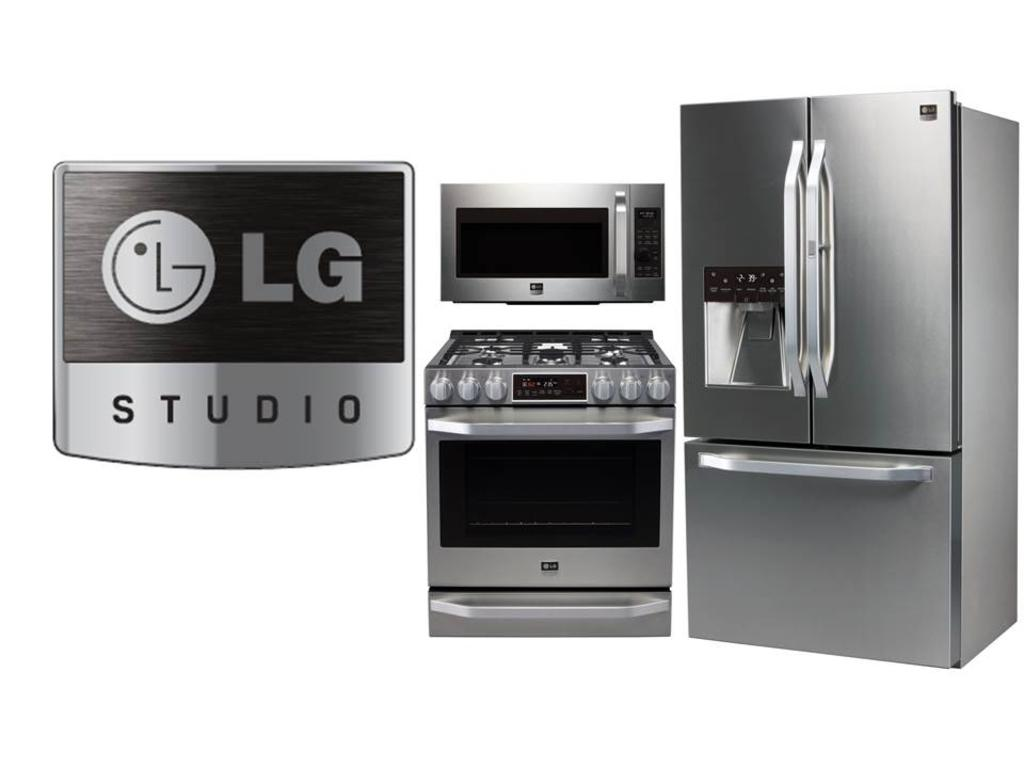What type of appliance can be seen in the image? There is a refrigerator, an oven, and a stove in the image. What other feature is present in the image? There is a logo with text in the image. What type of suit is the refrigerator wearing in the image? There is no suit present in the image, as the refrigerator is an appliance and not a person. 